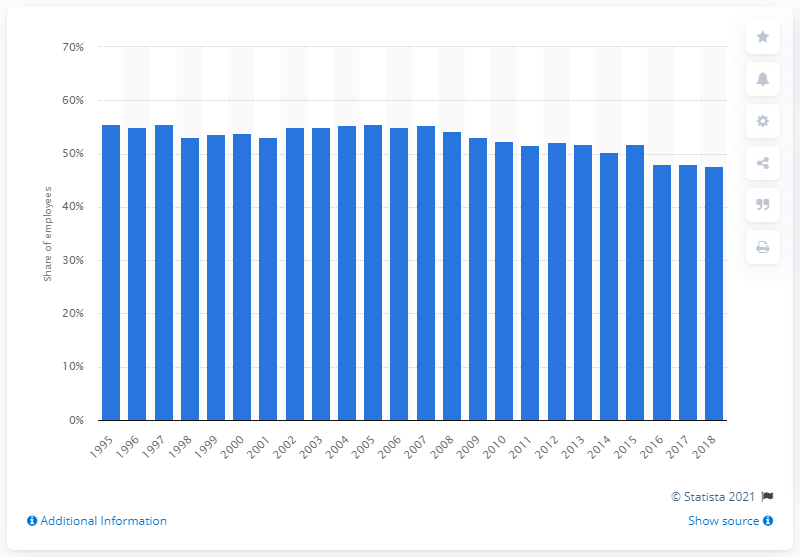List a handful of essential elements in this visual. In 2018, the trade union density in the education sector was 47.6%. 